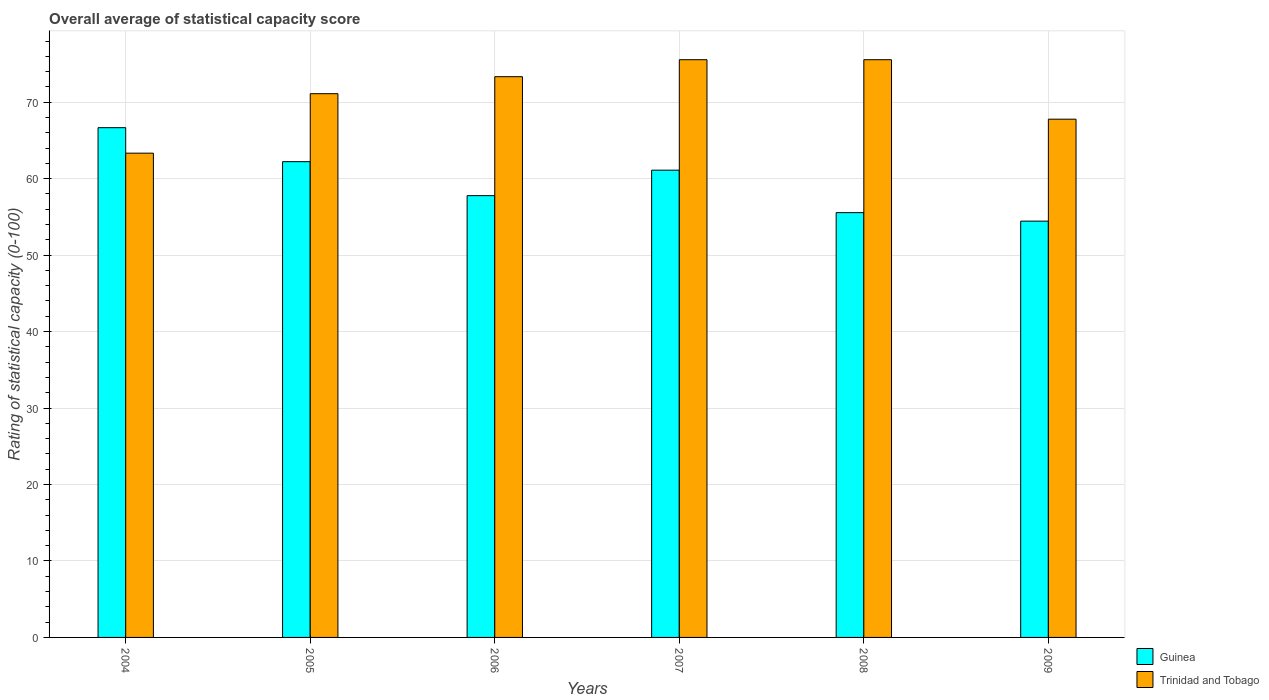How many groups of bars are there?
Offer a terse response. 6. Are the number of bars per tick equal to the number of legend labels?
Keep it short and to the point. Yes. What is the rating of statistical capacity in Guinea in 2009?
Your response must be concise. 54.44. Across all years, what is the maximum rating of statistical capacity in Guinea?
Your response must be concise. 66.67. Across all years, what is the minimum rating of statistical capacity in Trinidad and Tobago?
Keep it short and to the point. 63.33. In which year was the rating of statistical capacity in Guinea maximum?
Ensure brevity in your answer.  2004. In which year was the rating of statistical capacity in Trinidad and Tobago minimum?
Provide a succinct answer. 2004. What is the total rating of statistical capacity in Guinea in the graph?
Your answer should be very brief. 357.78. What is the difference between the rating of statistical capacity in Trinidad and Tobago in 2004 and that in 2009?
Make the answer very short. -4.44. What is the difference between the rating of statistical capacity in Trinidad and Tobago in 2009 and the rating of statistical capacity in Guinea in 2004?
Make the answer very short. 1.11. What is the average rating of statistical capacity in Trinidad and Tobago per year?
Give a very brief answer. 71.11. In the year 2008, what is the difference between the rating of statistical capacity in Trinidad and Tobago and rating of statistical capacity in Guinea?
Your response must be concise. 20. In how many years, is the rating of statistical capacity in Guinea greater than 14?
Offer a terse response. 6. What is the ratio of the rating of statistical capacity in Trinidad and Tobago in 2004 to that in 2006?
Keep it short and to the point. 0.86. Is the rating of statistical capacity in Trinidad and Tobago in 2004 less than that in 2006?
Make the answer very short. Yes. What is the difference between the highest and the second highest rating of statistical capacity in Trinidad and Tobago?
Your response must be concise. 0. What is the difference between the highest and the lowest rating of statistical capacity in Guinea?
Provide a succinct answer. 12.22. Is the sum of the rating of statistical capacity in Trinidad and Tobago in 2006 and 2009 greater than the maximum rating of statistical capacity in Guinea across all years?
Keep it short and to the point. Yes. What does the 1st bar from the left in 2007 represents?
Offer a terse response. Guinea. What does the 2nd bar from the right in 2009 represents?
Your response must be concise. Guinea. How many bars are there?
Keep it short and to the point. 12. What is the difference between two consecutive major ticks on the Y-axis?
Provide a succinct answer. 10. Are the values on the major ticks of Y-axis written in scientific E-notation?
Offer a very short reply. No. Does the graph contain any zero values?
Your response must be concise. No. Where does the legend appear in the graph?
Provide a succinct answer. Bottom right. How many legend labels are there?
Make the answer very short. 2. How are the legend labels stacked?
Provide a short and direct response. Vertical. What is the title of the graph?
Your answer should be very brief. Overall average of statistical capacity score. What is the label or title of the X-axis?
Your response must be concise. Years. What is the label or title of the Y-axis?
Your response must be concise. Rating of statistical capacity (0-100). What is the Rating of statistical capacity (0-100) in Guinea in 2004?
Provide a succinct answer. 66.67. What is the Rating of statistical capacity (0-100) in Trinidad and Tobago in 2004?
Your answer should be very brief. 63.33. What is the Rating of statistical capacity (0-100) of Guinea in 2005?
Provide a succinct answer. 62.22. What is the Rating of statistical capacity (0-100) of Trinidad and Tobago in 2005?
Offer a terse response. 71.11. What is the Rating of statistical capacity (0-100) of Guinea in 2006?
Offer a terse response. 57.78. What is the Rating of statistical capacity (0-100) in Trinidad and Tobago in 2006?
Offer a terse response. 73.33. What is the Rating of statistical capacity (0-100) of Guinea in 2007?
Ensure brevity in your answer.  61.11. What is the Rating of statistical capacity (0-100) in Trinidad and Tobago in 2007?
Provide a short and direct response. 75.56. What is the Rating of statistical capacity (0-100) in Guinea in 2008?
Your answer should be compact. 55.56. What is the Rating of statistical capacity (0-100) in Trinidad and Tobago in 2008?
Make the answer very short. 75.56. What is the Rating of statistical capacity (0-100) of Guinea in 2009?
Provide a short and direct response. 54.44. What is the Rating of statistical capacity (0-100) in Trinidad and Tobago in 2009?
Provide a short and direct response. 67.78. Across all years, what is the maximum Rating of statistical capacity (0-100) in Guinea?
Keep it short and to the point. 66.67. Across all years, what is the maximum Rating of statistical capacity (0-100) of Trinidad and Tobago?
Offer a terse response. 75.56. Across all years, what is the minimum Rating of statistical capacity (0-100) in Guinea?
Your answer should be compact. 54.44. Across all years, what is the minimum Rating of statistical capacity (0-100) of Trinidad and Tobago?
Your answer should be compact. 63.33. What is the total Rating of statistical capacity (0-100) of Guinea in the graph?
Keep it short and to the point. 357.78. What is the total Rating of statistical capacity (0-100) in Trinidad and Tobago in the graph?
Make the answer very short. 426.67. What is the difference between the Rating of statistical capacity (0-100) of Guinea in 2004 and that in 2005?
Your answer should be compact. 4.44. What is the difference between the Rating of statistical capacity (0-100) of Trinidad and Tobago in 2004 and that in 2005?
Keep it short and to the point. -7.78. What is the difference between the Rating of statistical capacity (0-100) of Guinea in 2004 and that in 2006?
Give a very brief answer. 8.89. What is the difference between the Rating of statistical capacity (0-100) in Guinea in 2004 and that in 2007?
Ensure brevity in your answer.  5.56. What is the difference between the Rating of statistical capacity (0-100) in Trinidad and Tobago in 2004 and that in 2007?
Provide a succinct answer. -12.22. What is the difference between the Rating of statistical capacity (0-100) in Guinea in 2004 and that in 2008?
Offer a very short reply. 11.11. What is the difference between the Rating of statistical capacity (0-100) in Trinidad and Tobago in 2004 and that in 2008?
Give a very brief answer. -12.22. What is the difference between the Rating of statistical capacity (0-100) of Guinea in 2004 and that in 2009?
Your answer should be compact. 12.22. What is the difference between the Rating of statistical capacity (0-100) of Trinidad and Tobago in 2004 and that in 2009?
Make the answer very short. -4.44. What is the difference between the Rating of statistical capacity (0-100) in Guinea in 2005 and that in 2006?
Ensure brevity in your answer.  4.44. What is the difference between the Rating of statistical capacity (0-100) in Trinidad and Tobago in 2005 and that in 2006?
Offer a terse response. -2.22. What is the difference between the Rating of statistical capacity (0-100) in Trinidad and Tobago in 2005 and that in 2007?
Your answer should be very brief. -4.44. What is the difference between the Rating of statistical capacity (0-100) in Guinea in 2005 and that in 2008?
Your response must be concise. 6.67. What is the difference between the Rating of statistical capacity (0-100) in Trinidad and Tobago in 2005 and that in 2008?
Your response must be concise. -4.44. What is the difference between the Rating of statistical capacity (0-100) of Guinea in 2005 and that in 2009?
Offer a terse response. 7.78. What is the difference between the Rating of statistical capacity (0-100) of Trinidad and Tobago in 2006 and that in 2007?
Your response must be concise. -2.22. What is the difference between the Rating of statistical capacity (0-100) in Guinea in 2006 and that in 2008?
Give a very brief answer. 2.22. What is the difference between the Rating of statistical capacity (0-100) in Trinidad and Tobago in 2006 and that in 2008?
Your response must be concise. -2.22. What is the difference between the Rating of statistical capacity (0-100) of Trinidad and Tobago in 2006 and that in 2009?
Ensure brevity in your answer.  5.56. What is the difference between the Rating of statistical capacity (0-100) in Guinea in 2007 and that in 2008?
Your answer should be compact. 5.56. What is the difference between the Rating of statistical capacity (0-100) of Trinidad and Tobago in 2007 and that in 2009?
Ensure brevity in your answer.  7.78. What is the difference between the Rating of statistical capacity (0-100) in Trinidad and Tobago in 2008 and that in 2009?
Your answer should be very brief. 7.78. What is the difference between the Rating of statistical capacity (0-100) in Guinea in 2004 and the Rating of statistical capacity (0-100) in Trinidad and Tobago in 2005?
Provide a succinct answer. -4.44. What is the difference between the Rating of statistical capacity (0-100) in Guinea in 2004 and the Rating of statistical capacity (0-100) in Trinidad and Tobago in 2006?
Provide a succinct answer. -6.67. What is the difference between the Rating of statistical capacity (0-100) of Guinea in 2004 and the Rating of statistical capacity (0-100) of Trinidad and Tobago in 2007?
Give a very brief answer. -8.89. What is the difference between the Rating of statistical capacity (0-100) of Guinea in 2004 and the Rating of statistical capacity (0-100) of Trinidad and Tobago in 2008?
Keep it short and to the point. -8.89. What is the difference between the Rating of statistical capacity (0-100) of Guinea in 2004 and the Rating of statistical capacity (0-100) of Trinidad and Tobago in 2009?
Give a very brief answer. -1.11. What is the difference between the Rating of statistical capacity (0-100) in Guinea in 2005 and the Rating of statistical capacity (0-100) in Trinidad and Tobago in 2006?
Keep it short and to the point. -11.11. What is the difference between the Rating of statistical capacity (0-100) of Guinea in 2005 and the Rating of statistical capacity (0-100) of Trinidad and Tobago in 2007?
Keep it short and to the point. -13.33. What is the difference between the Rating of statistical capacity (0-100) in Guinea in 2005 and the Rating of statistical capacity (0-100) in Trinidad and Tobago in 2008?
Ensure brevity in your answer.  -13.33. What is the difference between the Rating of statistical capacity (0-100) of Guinea in 2005 and the Rating of statistical capacity (0-100) of Trinidad and Tobago in 2009?
Ensure brevity in your answer.  -5.56. What is the difference between the Rating of statistical capacity (0-100) in Guinea in 2006 and the Rating of statistical capacity (0-100) in Trinidad and Tobago in 2007?
Keep it short and to the point. -17.78. What is the difference between the Rating of statistical capacity (0-100) in Guinea in 2006 and the Rating of statistical capacity (0-100) in Trinidad and Tobago in 2008?
Offer a very short reply. -17.78. What is the difference between the Rating of statistical capacity (0-100) in Guinea in 2007 and the Rating of statistical capacity (0-100) in Trinidad and Tobago in 2008?
Ensure brevity in your answer.  -14.44. What is the difference between the Rating of statistical capacity (0-100) of Guinea in 2007 and the Rating of statistical capacity (0-100) of Trinidad and Tobago in 2009?
Your response must be concise. -6.67. What is the difference between the Rating of statistical capacity (0-100) of Guinea in 2008 and the Rating of statistical capacity (0-100) of Trinidad and Tobago in 2009?
Make the answer very short. -12.22. What is the average Rating of statistical capacity (0-100) of Guinea per year?
Your response must be concise. 59.63. What is the average Rating of statistical capacity (0-100) in Trinidad and Tobago per year?
Offer a very short reply. 71.11. In the year 2004, what is the difference between the Rating of statistical capacity (0-100) of Guinea and Rating of statistical capacity (0-100) of Trinidad and Tobago?
Your answer should be very brief. 3.33. In the year 2005, what is the difference between the Rating of statistical capacity (0-100) in Guinea and Rating of statistical capacity (0-100) in Trinidad and Tobago?
Make the answer very short. -8.89. In the year 2006, what is the difference between the Rating of statistical capacity (0-100) of Guinea and Rating of statistical capacity (0-100) of Trinidad and Tobago?
Offer a terse response. -15.56. In the year 2007, what is the difference between the Rating of statistical capacity (0-100) in Guinea and Rating of statistical capacity (0-100) in Trinidad and Tobago?
Offer a terse response. -14.44. In the year 2008, what is the difference between the Rating of statistical capacity (0-100) of Guinea and Rating of statistical capacity (0-100) of Trinidad and Tobago?
Your answer should be compact. -20. In the year 2009, what is the difference between the Rating of statistical capacity (0-100) in Guinea and Rating of statistical capacity (0-100) in Trinidad and Tobago?
Provide a succinct answer. -13.33. What is the ratio of the Rating of statistical capacity (0-100) of Guinea in 2004 to that in 2005?
Your response must be concise. 1.07. What is the ratio of the Rating of statistical capacity (0-100) of Trinidad and Tobago in 2004 to that in 2005?
Offer a terse response. 0.89. What is the ratio of the Rating of statistical capacity (0-100) of Guinea in 2004 to that in 2006?
Keep it short and to the point. 1.15. What is the ratio of the Rating of statistical capacity (0-100) in Trinidad and Tobago in 2004 to that in 2006?
Your answer should be compact. 0.86. What is the ratio of the Rating of statistical capacity (0-100) in Trinidad and Tobago in 2004 to that in 2007?
Offer a very short reply. 0.84. What is the ratio of the Rating of statistical capacity (0-100) of Trinidad and Tobago in 2004 to that in 2008?
Provide a short and direct response. 0.84. What is the ratio of the Rating of statistical capacity (0-100) in Guinea in 2004 to that in 2009?
Give a very brief answer. 1.22. What is the ratio of the Rating of statistical capacity (0-100) of Trinidad and Tobago in 2004 to that in 2009?
Provide a short and direct response. 0.93. What is the ratio of the Rating of statistical capacity (0-100) in Guinea in 2005 to that in 2006?
Ensure brevity in your answer.  1.08. What is the ratio of the Rating of statistical capacity (0-100) of Trinidad and Tobago in 2005 to that in 2006?
Your answer should be very brief. 0.97. What is the ratio of the Rating of statistical capacity (0-100) of Guinea in 2005 to that in 2007?
Make the answer very short. 1.02. What is the ratio of the Rating of statistical capacity (0-100) of Guinea in 2005 to that in 2008?
Make the answer very short. 1.12. What is the ratio of the Rating of statistical capacity (0-100) in Trinidad and Tobago in 2005 to that in 2009?
Make the answer very short. 1.05. What is the ratio of the Rating of statistical capacity (0-100) of Guinea in 2006 to that in 2007?
Offer a very short reply. 0.95. What is the ratio of the Rating of statistical capacity (0-100) of Trinidad and Tobago in 2006 to that in 2007?
Your answer should be compact. 0.97. What is the ratio of the Rating of statistical capacity (0-100) in Trinidad and Tobago in 2006 to that in 2008?
Provide a succinct answer. 0.97. What is the ratio of the Rating of statistical capacity (0-100) in Guinea in 2006 to that in 2009?
Provide a short and direct response. 1.06. What is the ratio of the Rating of statistical capacity (0-100) of Trinidad and Tobago in 2006 to that in 2009?
Your answer should be very brief. 1.08. What is the ratio of the Rating of statistical capacity (0-100) of Trinidad and Tobago in 2007 to that in 2008?
Your response must be concise. 1. What is the ratio of the Rating of statistical capacity (0-100) of Guinea in 2007 to that in 2009?
Offer a very short reply. 1.12. What is the ratio of the Rating of statistical capacity (0-100) in Trinidad and Tobago in 2007 to that in 2009?
Keep it short and to the point. 1.11. What is the ratio of the Rating of statistical capacity (0-100) in Guinea in 2008 to that in 2009?
Give a very brief answer. 1.02. What is the ratio of the Rating of statistical capacity (0-100) of Trinidad and Tobago in 2008 to that in 2009?
Offer a very short reply. 1.11. What is the difference between the highest and the second highest Rating of statistical capacity (0-100) in Guinea?
Offer a terse response. 4.44. What is the difference between the highest and the second highest Rating of statistical capacity (0-100) in Trinidad and Tobago?
Offer a very short reply. 0. What is the difference between the highest and the lowest Rating of statistical capacity (0-100) of Guinea?
Keep it short and to the point. 12.22. What is the difference between the highest and the lowest Rating of statistical capacity (0-100) of Trinidad and Tobago?
Offer a very short reply. 12.22. 